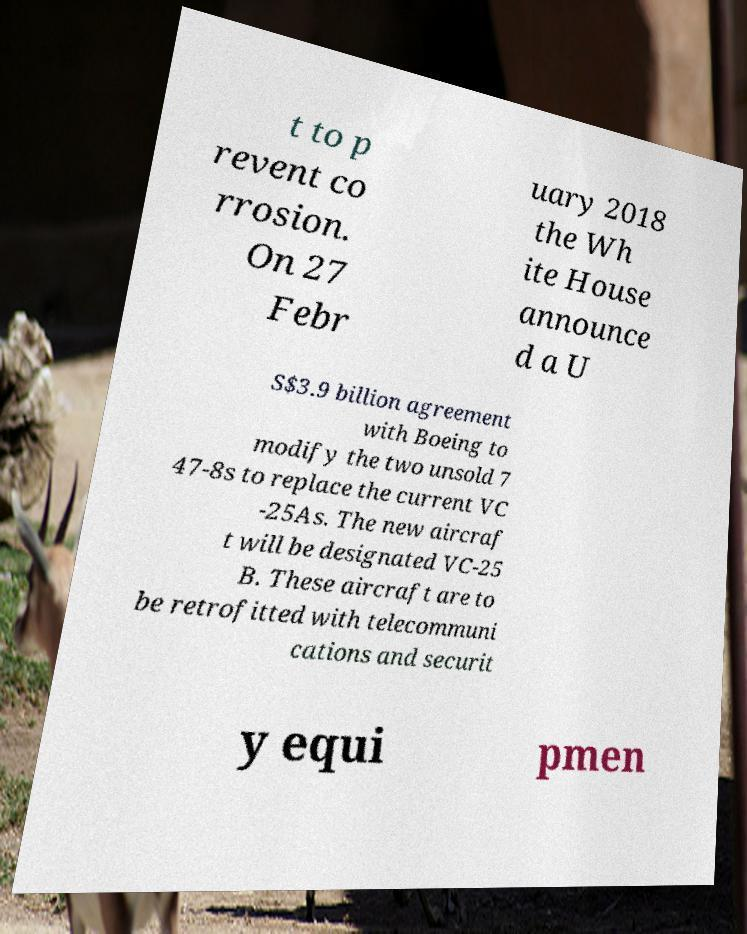Please identify and transcribe the text found in this image. t to p revent co rrosion. On 27 Febr uary 2018 the Wh ite House announce d a U S$3.9 billion agreement with Boeing to modify the two unsold 7 47-8s to replace the current VC -25As. The new aircraf t will be designated VC-25 B. These aircraft are to be retrofitted with telecommuni cations and securit y equi pmen 